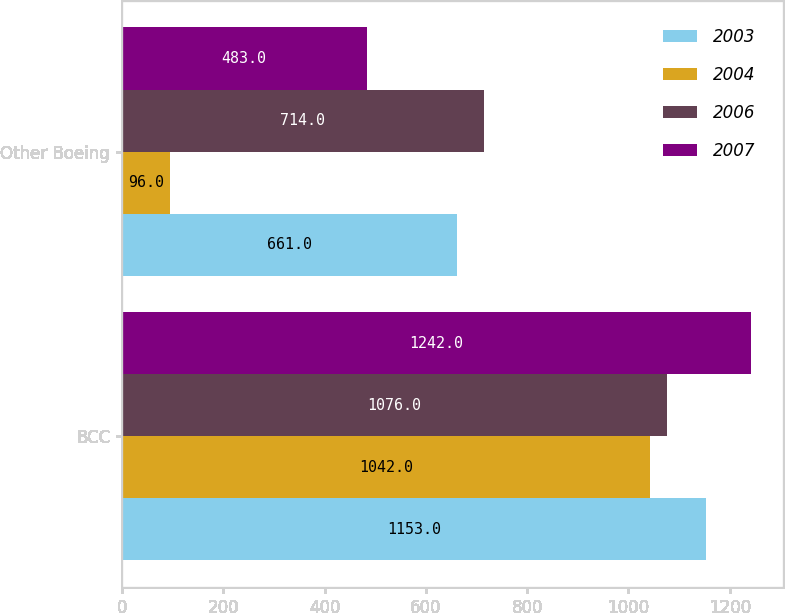Convert chart to OTSL. <chart><loc_0><loc_0><loc_500><loc_500><stacked_bar_chart><ecel><fcel>BCC<fcel>Other Boeing<nl><fcel>2003<fcel>1153<fcel>661<nl><fcel>2004<fcel>1042<fcel>96<nl><fcel>2006<fcel>1076<fcel>714<nl><fcel>2007<fcel>1242<fcel>483<nl></chart> 